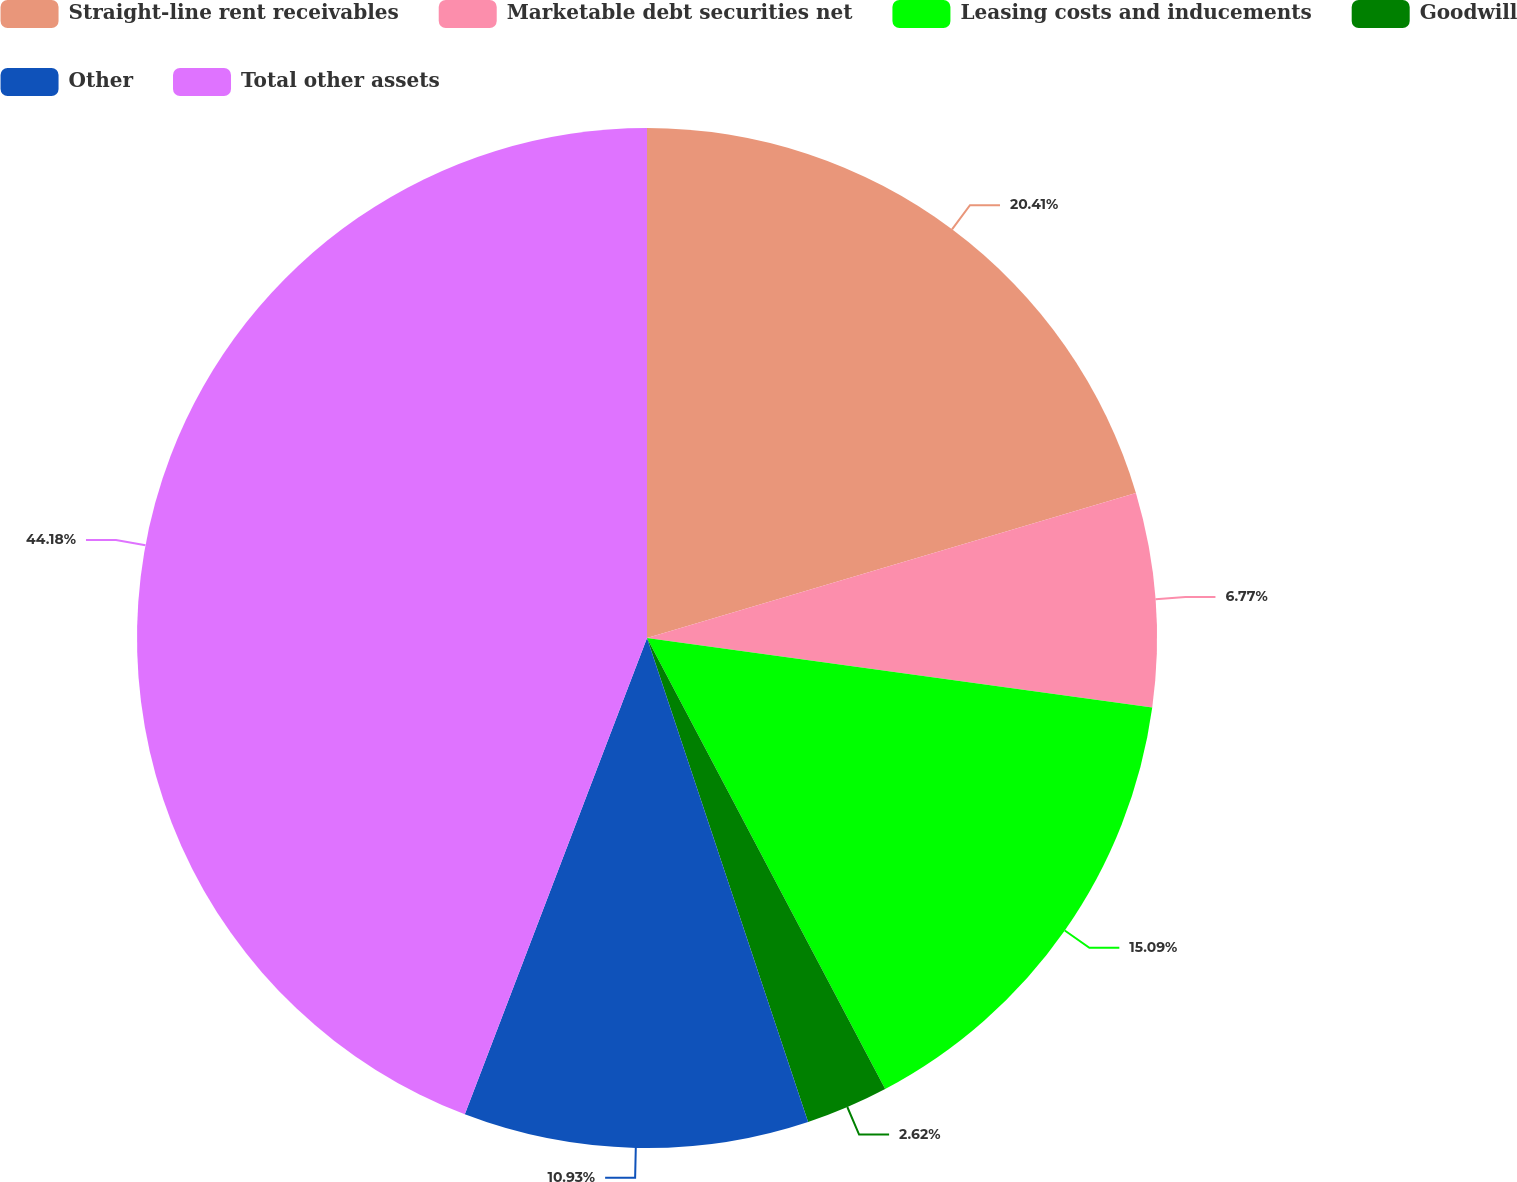Convert chart to OTSL. <chart><loc_0><loc_0><loc_500><loc_500><pie_chart><fcel>Straight-line rent receivables<fcel>Marketable debt securities net<fcel>Leasing costs and inducements<fcel>Goodwill<fcel>Other<fcel>Total other assets<nl><fcel>20.41%<fcel>6.77%<fcel>15.09%<fcel>2.62%<fcel>10.93%<fcel>44.19%<nl></chart> 